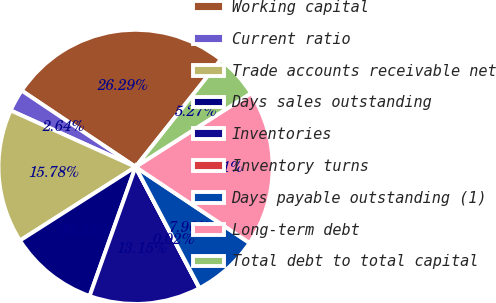Convert chart to OTSL. <chart><loc_0><loc_0><loc_500><loc_500><pie_chart><fcel>Working capital<fcel>Current ratio<fcel>Trade accounts receivable net<fcel>Days sales outstanding<fcel>Inventories<fcel>Inventory turns<fcel>Days payable outstanding (1)<fcel>Long-term debt<fcel>Total debt to total capital<nl><fcel>26.29%<fcel>2.64%<fcel>15.78%<fcel>10.53%<fcel>13.15%<fcel>0.02%<fcel>7.9%<fcel>18.41%<fcel>5.27%<nl></chart> 